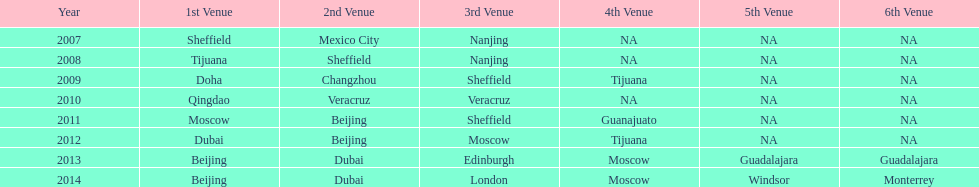Could you parse the entire table as a dict? {'header': ['Year', '1st Venue', '2nd Venue', '3rd Venue', '4th Venue', '5th Venue', '6th Venue'], 'rows': [['2007', 'Sheffield', 'Mexico City', 'Nanjing', 'NA', 'NA', 'NA'], ['2008', 'Tijuana', 'Sheffield', 'Nanjing', 'NA', 'NA', 'NA'], ['2009', 'Doha', 'Changzhou', 'Sheffield', 'Tijuana', 'NA', 'NA'], ['2010', 'Qingdao', 'Veracruz', 'Veracruz', 'NA', 'NA', 'NA'], ['2011', 'Moscow', 'Beijing', 'Sheffield', 'Guanajuato', 'NA', 'NA'], ['2012', 'Dubai', 'Beijing', 'Moscow', 'Tijuana', 'NA', 'NA'], ['2013', 'Beijing', 'Dubai', 'Edinburgh', 'Moscow', 'Guadalajara', 'Guadalajara'], ['2014', 'Beijing', 'Dubai', 'London', 'Moscow', 'Windsor', 'Monterrey']]} How long, in years, has the this world series been occurring? 7 years. 